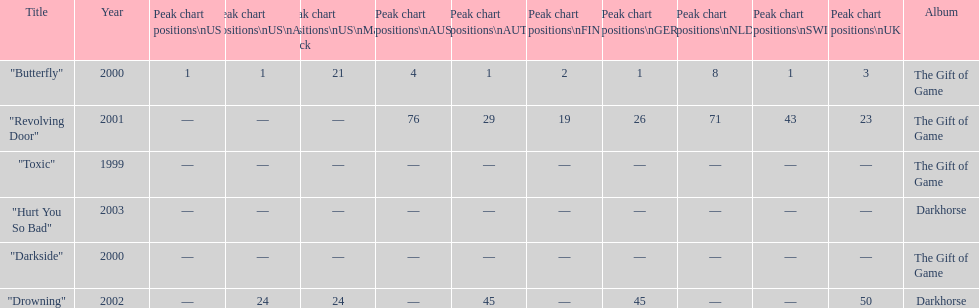Could you parse the entire table as a dict? {'header': ['Title', 'Year', 'Peak chart positions\\nUS', 'Peak chart positions\\nUS\\nAlt.', 'Peak chart positions\\nUS\\nMain. Rock', 'Peak chart positions\\nAUS', 'Peak chart positions\\nAUT', 'Peak chart positions\\nFIN', 'Peak chart positions\\nGER', 'Peak chart positions\\nNLD', 'Peak chart positions\\nSWI', 'Peak chart positions\\nUK', 'Album'], 'rows': [['"Butterfly"', '2000', '1', '1', '21', '4', '1', '2', '1', '8', '1', '3', 'The Gift of Game'], ['"Revolving Door"', '2001', '—', '—', '—', '76', '29', '19', '26', '71', '43', '23', 'The Gift of Game'], ['"Toxic"', '1999', '—', '—', '—', '—', '—', '—', '—', '—', '—', '—', 'The Gift of Game'], ['"Hurt You So Bad"', '2003', '—', '—', '—', '—', '—', '—', '—', '—', '—', '—', 'Darkhorse'], ['"Darkside"', '2000', '—', '—', '—', '—', '—', '—', '—', '—', '—', '—', 'The Gift of Game'], ['"Drowning"', '2002', '—', '24', '24', '—', '45', '—', '45', '—', '—', '50', 'Darkhorse']]} When did "drowning" peak at 24 in the us alternate group? 2002. 